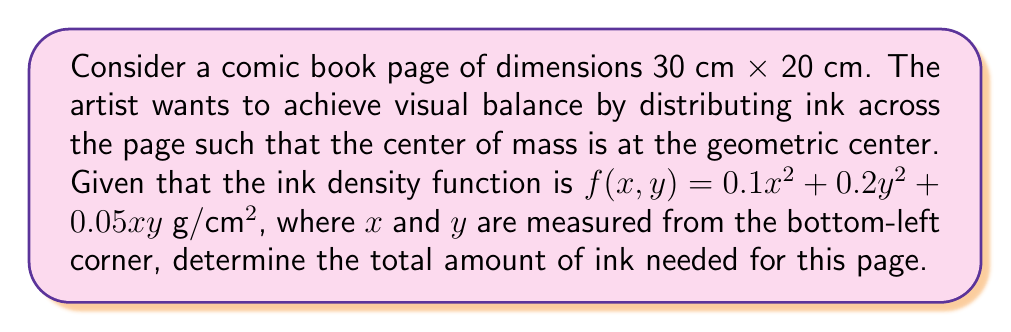Can you answer this question? Let's approach this step-by-step:

1) The center of mass for a 2D object is given by:

   $$\bar{x} = \frac{\int\int xf(x,y)dxdy}{\int\int f(x,y)dxdy}, \quad \bar{y} = \frac{\int\int yf(x,y)dxdy}{\int\int f(x,y)dxdy}$$

2) For visual balance, we want $\bar{x} = 15$ cm and $\bar{y} = 10$ cm.

3) The total amount of ink is given by the double integral of the density function:

   $$M = \int_0^{20} \int_0^{30} (0.1x^2 + 0.2y^2 + 0.05xy) dxdy$$

4) Let's solve this integral:

   $$M = \int_0^{20} \left[\frac{0.1x^3}{3} + 0.2xy^2 + \frac{0.05x^2y}{2}\right]_0^{30} dy$$

   $$= \int_0^{20} \left(3000 + 0.2(30)y^2 + 22.5y\right) dy$$

   $$= \left[3000y + 0.2(10)y^3 + 11.25y^2\right]_0^{20}$$

   $$= 60000 + 16000 + 4500 = 80500$$

5) Therefore, the total amount of ink needed is 80500 g or 80.5 kg.

Note: We didn't need to calculate the center of mass explicitly, as the question only asked for the total amount of ink.
Answer: 80.5 kg 